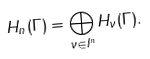<formula> <loc_0><loc_0><loc_500><loc_500>H _ { n } ( \Gamma ) = \bigoplus _ { \nu \in I ^ { n } } H _ { \nu } ( \Gamma ) .</formula> 